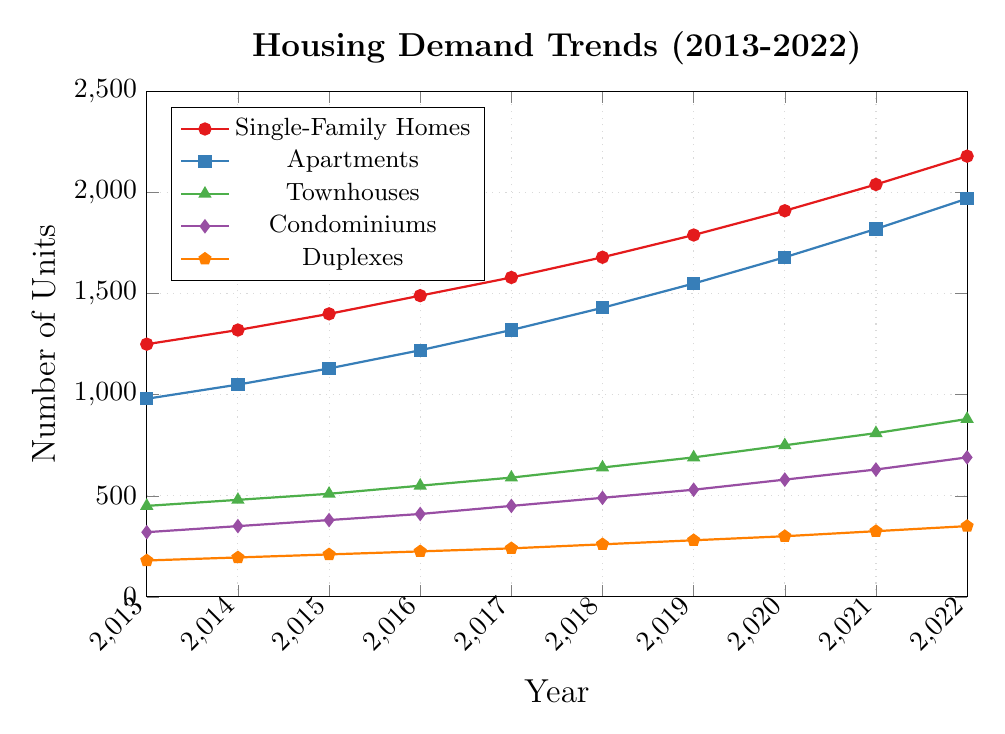What is the overall trend for single-family homes from 2013 to 2022? The line representing single-family homes increases steadily from 1250 units in 2013 to 2180 units in 2022, indicating an overall upward trend.
Answer: Upward trend Which property type had the highest increase in demand over the 10-year period? Single-family homes increased from 1250 units in 2013 to 2180 units in 2022, which is an increase of 930 units. Apartments increased by 990 units, which is higher than single-family homes. The other property types increased by lesser amounts.
Answer: Apartments In 2020, how does the demand for townhouses compare with that for condominiums? In 2020, townhouses are represented at 750 units and condominiums at 580 units. This indicates townhouses have a higher demand compared to condominiums in that year.
Answer: Townhouses have higher demand What is the average demand for duplexes over the decade? The values for duplex demand from 2013 to 2022 are: 180, 195, 210, 225, 240, 260, 280, 300, 325, and 350. Summing these values gives 2565; dividing by 10 (the number of years) gives an average demand of 256.5 units per year.
Answer: 256.5 units per year Which property type saw the least growth in demand from 2013 to 2022? Duplexes increased from 180 units in 2013 to 350 units in 2022, which is an increase of 170 units. All other property types showed a greater increase, so duplexes had the least growth.
Answer: Duplexes By how much did the demand for condominiums increase between 2017 and 2022? The demand for condominiums was 450 units in 2017 and increased to 690 units in 2022. The difference is 690 - 450 = 240 units.
Answer: 240 units How did the trend for single-family homes compare to apartments over the decade? Both property types show a similar upward trend from 2013 to 2022. Single-family homes increased from 1250 to 2180 units, while apartments increased from 980 to 1970 units. Both maintain a steady increase but single-family homes have slightly higher demand each year.
Answer: Similar upward trend In what year did the demand for townhouses surpass 600 units? According to the trend line, the demand for townhouses surpassed 600 units in 2018, where it reached 640 units.
Answer: 2018 What is the difference in the demand for single-family homes and duplexes in 2022? In 2022, there were 2180 units demanded for single-family homes and 350 units for duplexes. The difference is 2180 - 350 = 1830 units.
Answer: 1830 units 